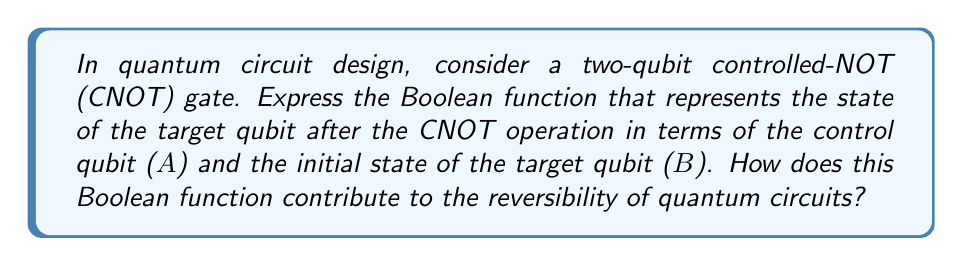Help me with this question. To solve this problem, let's approach it step-by-step:

1. Understand the CNOT gate:
   The CNOT gate flips the state of the target qubit if and only if the control qubit is in state |1⟩.

2. Express the Boolean function:
   Let A be the control qubit and B be the initial state of the target qubit.
   The final state of the target qubit (let's call it T) can be expressed as:
   
   $$T = A \oplus B$$
   
   Where $\oplus$ represents the XOR operation.

3. Verify the function:
   - If A = 0, T = 0 ⊕ B = B (target qubit unchanged)
   - If A = 1, T = 1 ⊕ B = NOT(B) (target qubit flipped)

4. Reversibility:
   The Boolean function $T = A \oplus B$ is bijective, meaning it has a one-to-one correspondence between inputs and outputs. This property ensures that:
   
   $$B = A \oplus T$$
   
   Thus, given the control qubit A and the final state T, we can always recover the initial state B.

5. Contribution to quantum circuit reversibility:
   - Preserves quantum information: No information is lost during the operation.
   - Allows for uncomputation: The operation can be undone by applying the same CNOT gate again.
   - Maintains quantum superposition: The linearity of the XOR operation preserves superposition states.

6. Optimization implications:
   The simplicity of the Boolean function (single XOR operation) makes CNOT gates efficient building blocks for more complex quantum circuits, contributing to circuit optimization.
Answer: $T = A \oplus B$; bijective function ensures reversibility 